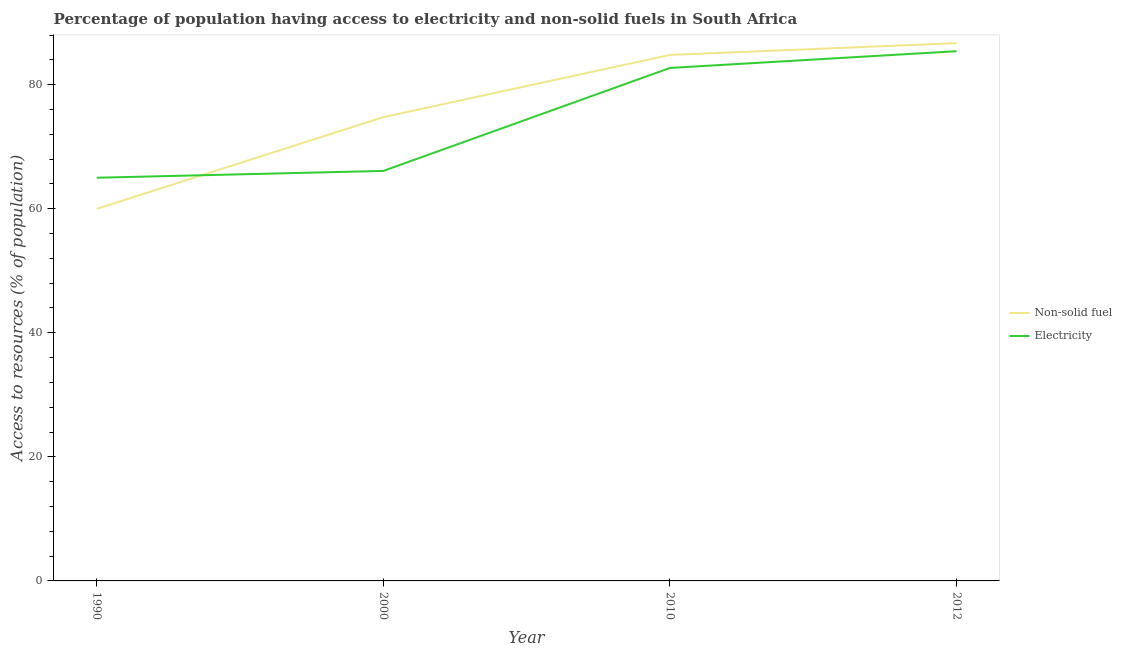How many different coloured lines are there?
Make the answer very short. 2. Is the number of lines equal to the number of legend labels?
Give a very brief answer. Yes. What is the percentage of population having access to electricity in 2000?
Give a very brief answer. 66.1. Across all years, what is the maximum percentage of population having access to non-solid fuel?
Keep it short and to the point. 86.7. Across all years, what is the minimum percentage of population having access to electricity?
Provide a short and direct response. 65. In which year was the percentage of population having access to non-solid fuel maximum?
Keep it short and to the point. 2012. What is the total percentage of population having access to electricity in the graph?
Ensure brevity in your answer.  299.2. What is the difference between the percentage of population having access to non-solid fuel in 1990 and that in 2010?
Give a very brief answer. -24.83. What is the difference between the percentage of population having access to electricity in 1990 and the percentage of population having access to non-solid fuel in 2000?
Your answer should be compact. -9.77. What is the average percentage of population having access to non-solid fuel per year?
Provide a succinct answer. 76.56. In the year 2012, what is the difference between the percentage of population having access to electricity and percentage of population having access to non-solid fuel?
Make the answer very short. -1.3. What is the ratio of the percentage of population having access to non-solid fuel in 2000 to that in 2010?
Make the answer very short. 0.88. Is the percentage of population having access to electricity in 2000 less than that in 2010?
Offer a very short reply. Yes. What is the difference between the highest and the second highest percentage of population having access to non-solid fuel?
Make the answer very short. 1.89. What is the difference between the highest and the lowest percentage of population having access to non-solid fuel?
Give a very brief answer. 26.72. Is the sum of the percentage of population having access to non-solid fuel in 2000 and 2010 greater than the maximum percentage of population having access to electricity across all years?
Offer a very short reply. Yes. Does the percentage of population having access to electricity monotonically increase over the years?
Make the answer very short. Yes. How many years are there in the graph?
Provide a succinct answer. 4. What is the difference between two consecutive major ticks on the Y-axis?
Keep it short and to the point. 20. How many legend labels are there?
Your answer should be very brief. 2. How are the legend labels stacked?
Provide a succinct answer. Vertical. What is the title of the graph?
Your answer should be very brief. Percentage of population having access to electricity and non-solid fuels in South Africa. Does "Under-5(male)" appear as one of the legend labels in the graph?
Provide a succinct answer. No. What is the label or title of the X-axis?
Give a very brief answer. Year. What is the label or title of the Y-axis?
Your answer should be compact. Access to resources (% of population). What is the Access to resources (% of population) of Non-solid fuel in 1990?
Ensure brevity in your answer.  59.98. What is the Access to resources (% of population) in Electricity in 1990?
Offer a terse response. 65. What is the Access to resources (% of population) of Non-solid fuel in 2000?
Offer a very short reply. 74.77. What is the Access to resources (% of population) of Electricity in 2000?
Your response must be concise. 66.1. What is the Access to resources (% of population) in Non-solid fuel in 2010?
Keep it short and to the point. 84.8. What is the Access to resources (% of population) of Electricity in 2010?
Provide a succinct answer. 82.7. What is the Access to resources (% of population) in Non-solid fuel in 2012?
Provide a short and direct response. 86.7. What is the Access to resources (% of population) of Electricity in 2012?
Your answer should be very brief. 85.4. Across all years, what is the maximum Access to resources (% of population) in Non-solid fuel?
Provide a short and direct response. 86.7. Across all years, what is the maximum Access to resources (% of population) in Electricity?
Ensure brevity in your answer.  85.4. Across all years, what is the minimum Access to resources (% of population) in Non-solid fuel?
Keep it short and to the point. 59.98. Across all years, what is the minimum Access to resources (% of population) in Electricity?
Your response must be concise. 65. What is the total Access to resources (% of population) of Non-solid fuel in the graph?
Offer a terse response. 306.24. What is the total Access to resources (% of population) of Electricity in the graph?
Make the answer very short. 299.2. What is the difference between the Access to resources (% of population) of Non-solid fuel in 1990 and that in 2000?
Your answer should be very brief. -14.79. What is the difference between the Access to resources (% of population) in Non-solid fuel in 1990 and that in 2010?
Make the answer very short. -24.82. What is the difference between the Access to resources (% of population) of Electricity in 1990 and that in 2010?
Offer a terse response. -17.7. What is the difference between the Access to resources (% of population) in Non-solid fuel in 1990 and that in 2012?
Offer a very short reply. -26.72. What is the difference between the Access to resources (% of population) of Electricity in 1990 and that in 2012?
Your response must be concise. -20.4. What is the difference between the Access to resources (% of population) in Non-solid fuel in 2000 and that in 2010?
Ensure brevity in your answer.  -10.04. What is the difference between the Access to resources (% of population) in Electricity in 2000 and that in 2010?
Provide a short and direct response. -16.6. What is the difference between the Access to resources (% of population) of Non-solid fuel in 2000 and that in 2012?
Your answer should be compact. -11.93. What is the difference between the Access to resources (% of population) in Electricity in 2000 and that in 2012?
Keep it short and to the point. -19.3. What is the difference between the Access to resources (% of population) in Non-solid fuel in 2010 and that in 2012?
Provide a succinct answer. -1.89. What is the difference between the Access to resources (% of population) of Non-solid fuel in 1990 and the Access to resources (% of population) of Electricity in 2000?
Your answer should be compact. -6.12. What is the difference between the Access to resources (% of population) of Non-solid fuel in 1990 and the Access to resources (% of population) of Electricity in 2010?
Provide a short and direct response. -22.72. What is the difference between the Access to resources (% of population) in Non-solid fuel in 1990 and the Access to resources (% of population) in Electricity in 2012?
Ensure brevity in your answer.  -25.42. What is the difference between the Access to resources (% of population) in Non-solid fuel in 2000 and the Access to resources (% of population) in Electricity in 2010?
Keep it short and to the point. -7.93. What is the difference between the Access to resources (% of population) in Non-solid fuel in 2000 and the Access to resources (% of population) in Electricity in 2012?
Your answer should be very brief. -10.63. What is the difference between the Access to resources (% of population) in Non-solid fuel in 2010 and the Access to resources (% of population) in Electricity in 2012?
Keep it short and to the point. -0.6. What is the average Access to resources (% of population) of Non-solid fuel per year?
Offer a very short reply. 76.56. What is the average Access to resources (% of population) in Electricity per year?
Offer a very short reply. 74.8. In the year 1990, what is the difference between the Access to resources (% of population) of Non-solid fuel and Access to resources (% of population) of Electricity?
Your response must be concise. -5.02. In the year 2000, what is the difference between the Access to resources (% of population) in Non-solid fuel and Access to resources (% of population) in Electricity?
Give a very brief answer. 8.67. In the year 2010, what is the difference between the Access to resources (% of population) of Non-solid fuel and Access to resources (% of population) of Electricity?
Your answer should be compact. 2.1. In the year 2012, what is the difference between the Access to resources (% of population) of Non-solid fuel and Access to resources (% of population) of Electricity?
Your answer should be compact. 1.3. What is the ratio of the Access to resources (% of population) in Non-solid fuel in 1990 to that in 2000?
Provide a short and direct response. 0.8. What is the ratio of the Access to resources (% of population) of Electricity in 1990 to that in 2000?
Your answer should be very brief. 0.98. What is the ratio of the Access to resources (% of population) of Non-solid fuel in 1990 to that in 2010?
Give a very brief answer. 0.71. What is the ratio of the Access to resources (% of population) in Electricity in 1990 to that in 2010?
Offer a terse response. 0.79. What is the ratio of the Access to resources (% of population) in Non-solid fuel in 1990 to that in 2012?
Offer a very short reply. 0.69. What is the ratio of the Access to resources (% of population) in Electricity in 1990 to that in 2012?
Your response must be concise. 0.76. What is the ratio of the Access to resources (% of population) of Non-solid fuel in 2000 to that in 2010?
Ensure brevity in your answer.  0.88. What is the ratio of the Access to resources (% of population) in Electricity in 2000 to that in 2010?
Your answer should be compact. 0.8. What is the ratio of the Access to resources (% of population) of Non-solid fuel in 2000 to that in 2012?
Provide a succinct answer. 0.86. What is the ratio of the Access to resources (% of population) in Electricity in 2000 to that in 2012?
Your answer should be very brief. 0.77. What is the ratio of the Access to resources (% of population) of Non-solid fuel in 2010 to that in 2012?
Give a very brief answer. 0.98. What is the ratio of the Access to resources (% of population) of Electricity in 2010 to that in 2012?
Give a very brief answer. 0.97. What is the difference between the highest and the second highest Access to resources (% of population) of Non-solid fuel?
Keep it short and to the point. 1.89. What is the difference between the highest and the lowest Access to resources (% of population) of Non-solid fuel?
Offer a terse response. 26.72. What is the difference between the highest and the lowest Access to resources (% of population) of Electricity?
Provide a succinct answer. 20.4. 